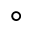Convert formula to latex. <formula><loc_0><loc_0><loc_500><loc_500>^ { \circ }</formula> 